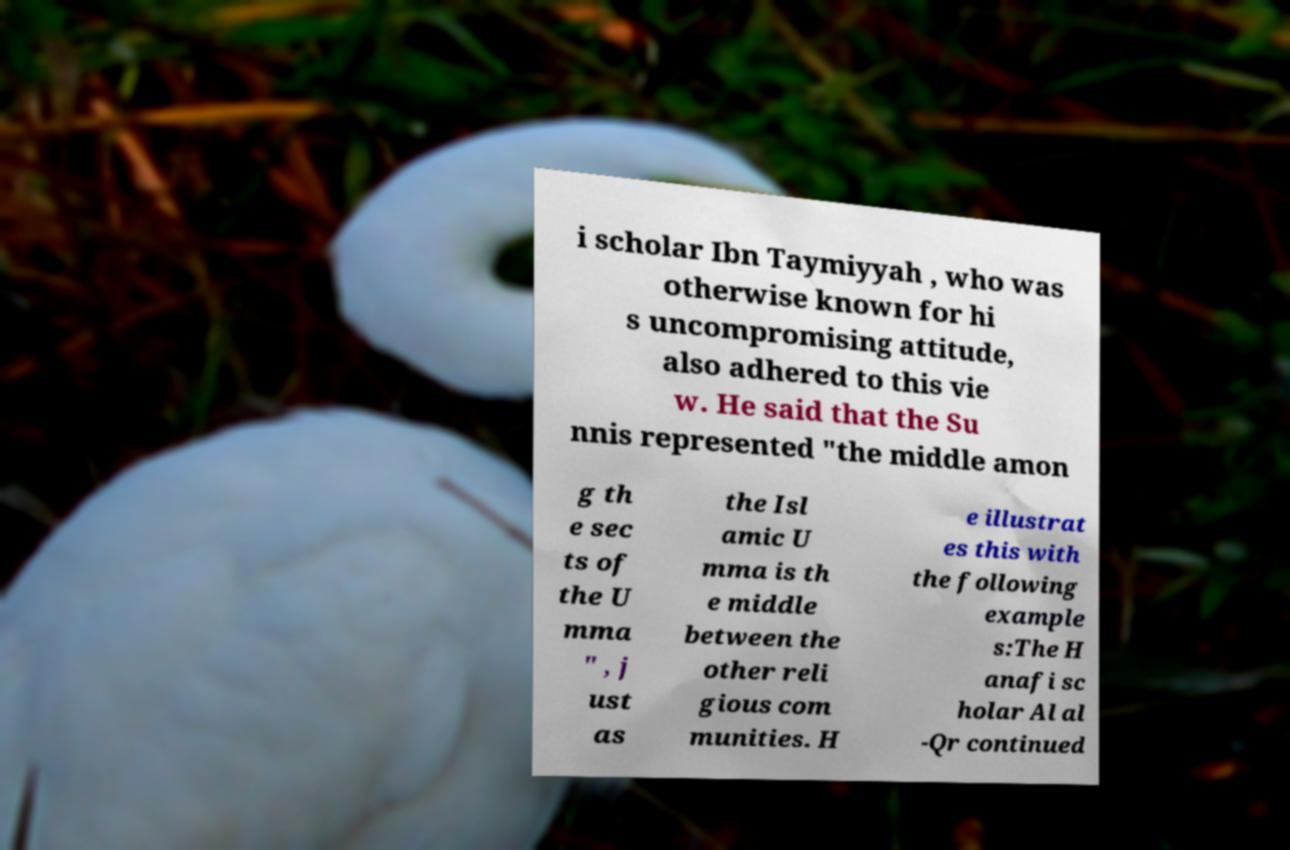Please identify and transcribe the text found in this image. i scholar Ibn Taymiyyah , who was otherwise known for hi s uncompromising attitude, also adhered to this vie w. He said that the Su nnis represented "the middle amon g th e sec ts of the U mma " , j ust as the Isl amic U mma is th e middle between the other reli gious com munities. H e illustrat es this with the following example s:The H anafi sc holar Al al -Qr continued 